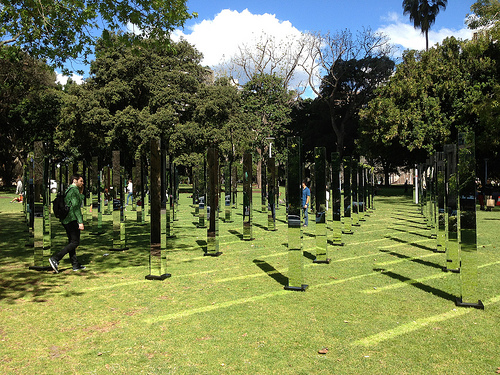<image>
Can you confirm if the tree is on the ground? Yes. Looking at the image, I can see the tree is positioned on top of the ground, with the ground providing support. Is the cloud behind the tree? Yes. From this viewpoint, the cloud is positioned behind the tree, with the tree partially or fully occluding the cloud. 